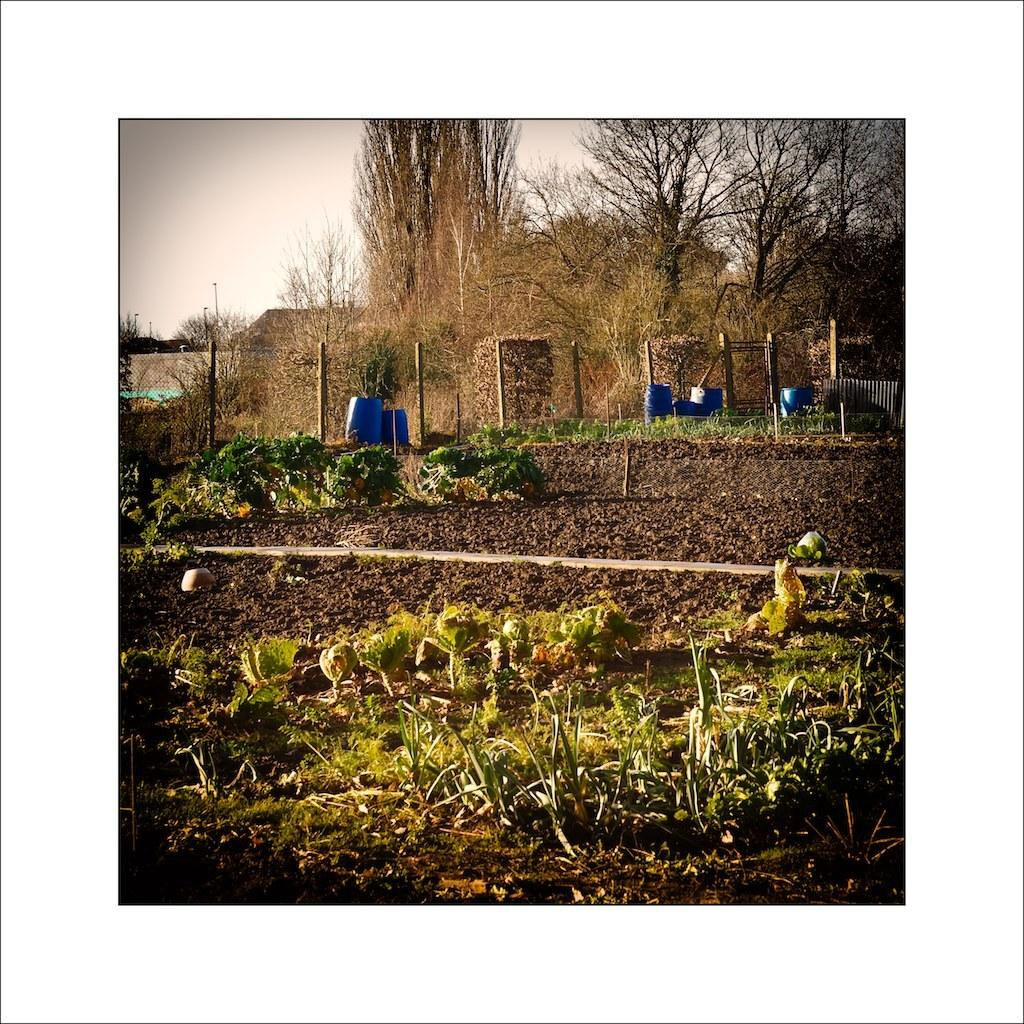What type of vegetation can be seen in the image? There are plants and trees in the image. What other objects can be seen in the image? There are barrels, poles, fencing, and houses in the image. What is visible in the background of the image? The sky is visible in the image. Where is the harbor located in the image? There is no harbor present in the image. What type of sheet is covering the plants in the image? There are no sheets covering the plants in the image; they are exposed to the open air. 